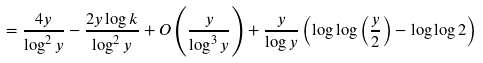<formula> <loc_0><loc_0><loc_500><loc_500>= \frac { 4 y } { \log ^ { 2 } y } - \frac { 2 y \log k } { \log ^ { 2 } y } + O \left ( \frac { y } { \log ^ { 3 } y } \right ) + \frac { y } { \log y } \left ( \log \log \left ( \frac { y } { 2 } \right ) - \log \log 2 \right )</formula> 